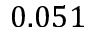Convert formula to latex. <formula><loc_0><loc_0><loc_500><loc_500>0 . 0 5 1</formula> 